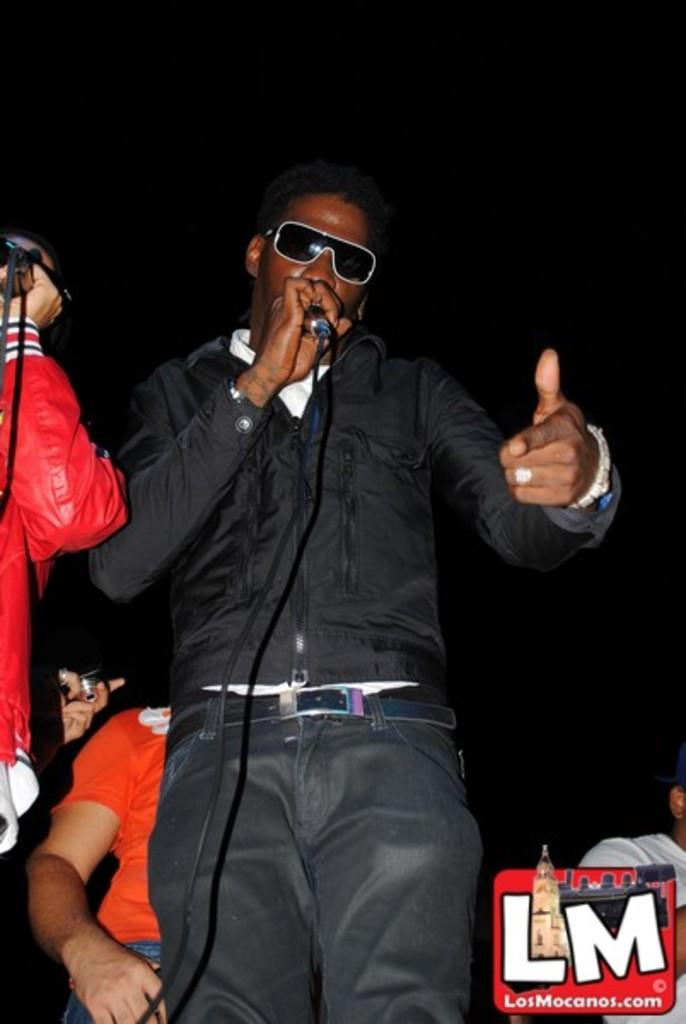What is the main subject of the image? There is a person in the image. What is the person wearing? The person is wearing a black shirt. What is the person holding? The person is holding a microphone. What is the person's posture in the image? The person is standing. Can you describe the background of the image? There are other people in the background, and one person is holding a camera. What type of noise can be heard coming from the hydrant in the image? There is no hydrant present in the image, so it's not possible to determine what, if any, noise might be heard. 